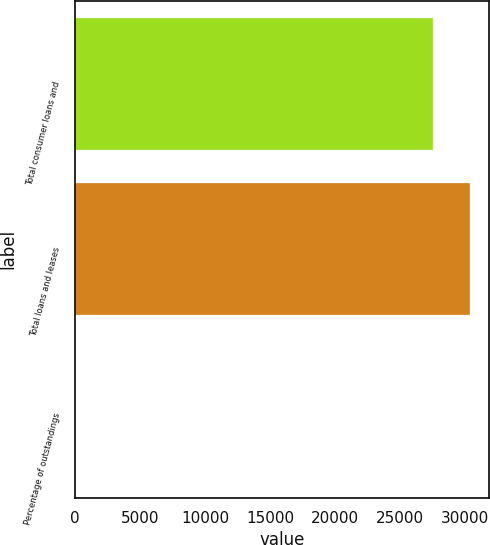Convert chart to OTSL. <chart><loc_0><loc_0><loc_500><loc_500><bar_chart><fcel>Total consumer loans and<fcel>Total loans and leases<fcel>Percentage of outstandings<nl><fcel>27533<fcel>30359<fcel>3.04<nl></chart> 